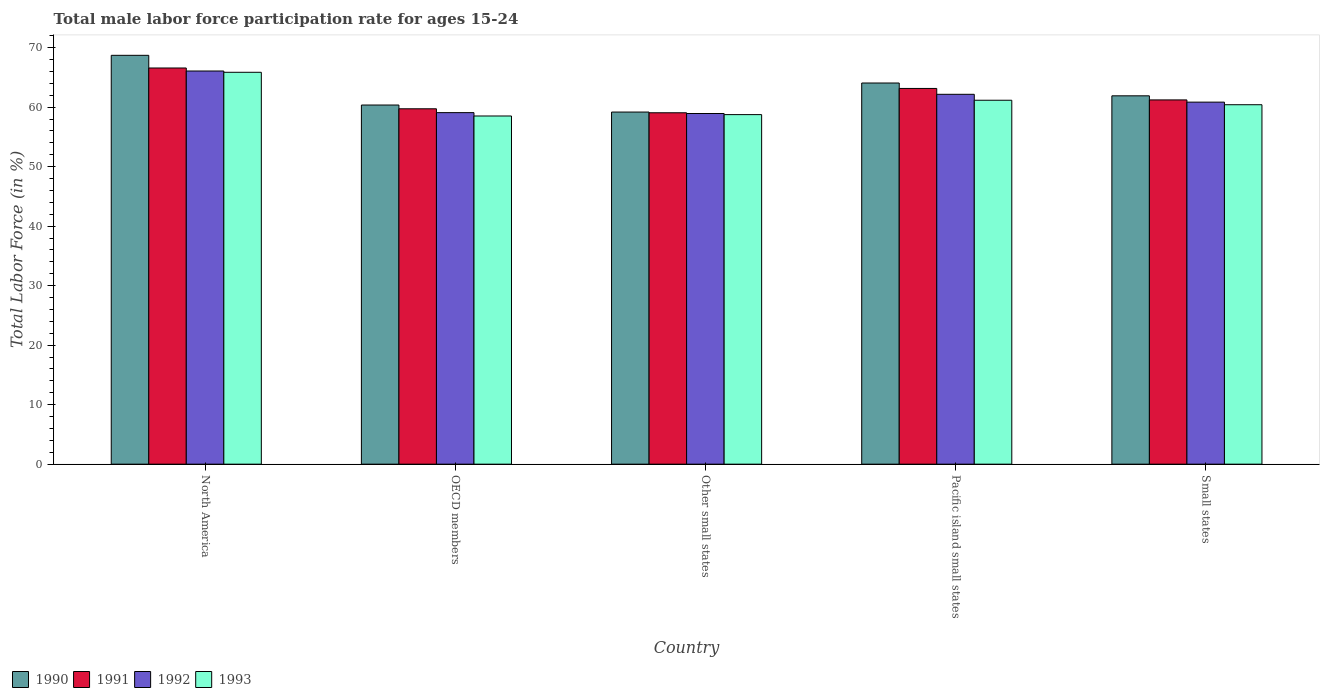Are the number of bars per tick equal to the number of legend labels?
Your answer should be very brief. Yes. Are the number of bars on each tick of the X-axis equal?
Give a very brief answer. Yes. How many bars are there on the 1st tick from the right?
Provide a succinct answer. 4. What is the label of the 3rd group of bars from the left?
Your answer should be compact. Other small states. In how many cases, is the number of bars for a given country not equal to the number of legend labels?
Ensure brevity in your answer.  0. What is the male labor force participation rate in 1990 in North America?
Keep it short and to the point. 68.71. Across all countries, what is the maximum male labor force participation rate in 1990?
Your answer should be very brief. 68.71. Across all countries, what is the minimum male labor force participation rate in 1993?
Your response must be concise. 58.51. In which country was the male labor force participation rate in 1991 maximum?
Your response must be concise. North America. In which country was the male labor force participation rate in 1992 minimum?
Offer a terse response. Other small states. What is the total male labor force participation rate in 1991 in the graph?
Your answer should be very brief. 309.72. What is the difference between the male labor force participation rate in 1992 in OECD members and that in Other small states?
Provide a short and direct response. 0.14. What is the difference between the male labor force participation rate in 1990 in Other small states and the male labor force participation rate in 1992 in North America?
Provide a succinct answer. -6.9. What is the average male labor force participation rate in 1991 per country?
Make the answer very short. 61.94. What is the difference between the male labor force participation rate of/in 1990 and male labor force participation rate of/in 1993 in Other small states?
Make the answer very short. 0.43. In how many countries, is the male labor force participation rate in 1993 greater than 18 %?
Your answer should be compact. 5. What is the ratio of the male labor force participation rate in 1993 in North America to that in Pacific island small states?
Your response must be concise. 1.08. Is the male labor force participation rate in 1993 in OECD members less than that in Pacific island small states?
Provide a short and direct response. Yes. What is the difference between the highest and the second highest male labor force participation rate in 1990?
Offer a terse response. -4.65. What is the difference between the highest and the lowest male labor force participation rate in 1990?
Ensure brevity in your answer.  9.54. In how many countries, is the male labor force participation rate in 1990 greater than the average male labor force participation rate in 1990 taken over all countries?
Give a very brief answer. 2. Is the sum of the male labor force participation rate in 1993 in North America and Other small states greater than the maximum male labor force participation rate in 1992 across all countries?
Your response must be concise. Yes. What does the 3rd bar from the left in North America represents?
Your answer should be compact. 1992. Is it the case that in every country, the sum of the male labor force participation rate in 1993 and male labor force participation rate in 1991 is greater than the male labor force participation rate in 1992?
Offer a terse response. Yes. How many bars are there?
Keep it short and to the point. 20. How many countries are there in the graph?
Provide a succinct answer. 5. What is the difference between two consecutive major ticks on the Y-axis?
Keep it short and to the point. 10. Are the values on the major ticks of Y-axis written in scientific E-notation?
Offer a terse response. No. Does the graph contain any zero values?
Provide a short and direct response. No. Does the graph contain grids?
Offer a very short reply. No. Where does the legend appear in the graph?
Ensure brevity in your answer.  Bottom left. How are the legend labels stacked?
Your answer should be very brief. Horizontal. What is the title of the graph?
Your response must be concise. Total male labor force participation rate for ages 15-24. What is the Total Labor Force (in %) of 1990 in North America?
Offer a terse response. 68.71. What is the Total Labor Force (in %) in 1991 in North America?
Give a very brief answer. 66.58. What is the Total Labor Force (in %) in 1992 in North America?
Offer a very short reply. 66.08. What is the Total Labor Force (in %) of 1993 in North America?
Ensure brevity in your answer.  65.86. What is the Total Labor Force (in %) of 1990 in OECD members?
Your answer should be very brief. 60.36. What is the Total Labor Force (in %) of 1991 in OECD members?
Your answer should be compact. 59.73. What is the Total Labor Force (in %) in 1992 in OECD members?
Make the answer very short. 59.08. What is the Total Labor Force (in %) of 1993 in OECD members?
Make the answer very short. 58.51. What is the Total Labor Force (in %) of 1990 in Other small states?
Offer a very short reply. 59.18. What is the Total Labor Force (in %) in 1991 in Other small states?
Your answer should be very brief. 59.05. What is the Total Labor Force (in %) in 1992 in Other small states?
Your answer should be compact. 58.93. What is the Total Labor Force (in %) in 1993 in Other small states?
Offer a terse response. 58.75. What is the Total Labor Force (in %) in 1990 in Pacific island small states?
Your answer should be very brief. 64.06. What is the Total Labor Force (in %) of 1991 in Pacific island small states?
Provide a short and direct response. 63.15. What is the Total Labor Force (in %) in 1992 in Pacific island small states?
Your answer should be compact. 62.16. What is the Total Labor Force (in %) of 1993 in Pacific island small states?
Offer a terse response. 61.16. What is the Total Labor Force (in %) in 1990 in Small states?
Ensure brevity in your answer.  61.9. What is the Total Labor Force (in %) of 1991 in Small states?
Make the answer very short. 61.22. What is the Total Labor Force (in %) in 1992 in Small states?
Provide a short and direct response. 60.84. What is the Total Labor Force (in %) in 1993 in Small states?
Offer a terse response. 60.41. Across all countries, what is the maximum Total Labor Force (in %) of 1990?
Provide a short and direct response. 68.71. Across all countries, what is the maximum Total Labor Force (in %) in 1991?
Your answer should be very brief. 66.58. Across all countries, what is the maximum Total Labor Force (in %) of 1992?
Provide a succinct answer. 66.08. Across all countries, what is the maximum Total Labor Force (in %) of 1993?
Your answer should be very brief. 65.86. Across all countries, what is the minimum Total Labor Force (in %) of 1990?
Your response must be concise. 59.18. Across all countries, what is the minimum Total Labor Force (in %) in 1991?
Keep it short and to the point. 59.05. Across all countries, what is the minimum Total Labor Force (in %) in 1992?
Offer a very short reply. 58.93. Across all countries, what is the minimum Total Labor Force (in %) of 1993?
Keep it short and to the point. 58.51. What is the total Total Labor Force (in %) in 1990 in the graph?
Provide a succinct answer. 314.21. What is the total Total Labor Force (in %) of 1991 in the graph?
Your answer should be very brief. 309.72. What is the total Total Labor Force (in %) in 1992 in the graph?
Keep it short and to the point. 307.09. What is the total Total Labor Force (in %) in 1993 in the graph?
Provide a short and direct response. 304.69. What is the difference between the Total Labor Force (in %) in 1990 in North America and that in OECD members?
Your answer should be compact. 8.35. What is the difference between the Total Labor Force (in %) in 1991 in North America and that in OECD members?
Your answer should be compact. 6.86. What is the difference between the Total Labor Force (in %) of 1992 in North America and that in OECD members?
Ensure brevity in your answer.  7. What is the difference between the Total Labor Force (in %) of 1993 in North America and that in OECD members?
Provide a succinct answer. 7.34. What is the difference between the Total Labor Force (in %) of 1990 in North America and that in Other small states?
Your response must be concise. 9.54. What is the difference between the Total Labor Force (in %) of 1991 in North America and that in Other small states?
Your answer should be compact. 7.53. What is the difference between the Total Labor Force (in %) of 1992 in North America and that in Other small states?
Give a very brief answer. 7.14. What is the difference between the Total Labor Force (in %) in 1993 in North America and that in Other small states?
Your response must be concise. 7.11. What is the difference between the Total Labor Force (in %) of 1990 in North America and that in Pacific island small states?
Your answer should be compact. 4.65. What is the difference between the Total Labor Force (in %) of 1991 in North America and that in Pacific island small states?
Your answer should be compact. 3.44. What is the difference between the Total Labor Force (in %) of 1992 in North America and that in Pacific island small states?
Ensure brevity in your answer.  3.92. What is the difference between the Total Labor Force (in %) in 1993 in North America and that in Pacific island small states?
Offer a terse response. 4.7. What is the difference between the Total Labor Force (in %) in 1990 in North America and that in Small states?
Give a very brief answer. 6.81. What is the difference between the Total Labor Force (in %) in 1991 in North America and that in Small states?
Make the answer very short. 5.36. What is the difference between the Total Labor Force (in %) of 1992 in North America and that in Small states?
Provide a short and direct response. 5.23. What is the difference between the Total Labor Force (in %) in 1993 in North America and that in Small states?
Offer a very short reply. 5.45. What is the difference between the Total Labor Force (in %) in 1990 in OECD members and that in Other small states?
Ensure brevity in your answer.  1.18. What is the difference between the Total Labor Force (in %) of 1991 in OECD members and that in Other small states?
Offer a very short reply. 0.67. What is the difference between the Total Labor Force (in %) in 1992 in OECD members and that in Other small states?
Your response must be concise. 0.14. What is the difference between the Total Labor Force (in %) of 1993 in OECD members and that in Other small states?
Keep it short and to the point. -0.23. What is the difference between the Total Labor Force (in %) of 1990 in OECD members and that in Pacific island small states?
Offer a very short reply. -3.7. What is the difference between the Total Labor Force (in %) in 1991 in OECD members and that in Pacific island small states?
Your answer should be very brief. -3.42. What is the difference between the Total Labor Force (in %) in 1992 in OECD members and that in Pacific island small states?
Give a very brief answer. -3.08. What is the difference between the Total Labor Force (in %) in 1993 in OECD members and that in Pacific island small states?
Give a very brief answer. -2.65. What is the difference between the Total Labor Force (in %) in 1990 in OECD members and that in Small states?
Offer a terse response. -1.55. What is the difference between the Total Labor Force (in %) in 1991 in OECD members and that in Small states?
Keep it short and to the point. -1.49. What is the difference between the Total Labor Force (in %) in 1992 in OECD members and that in Small states?
Make the answer very short. -1.76. What is the difference between the Total Labor Force (in %) in 1993 in OECD members and that in Small states?
Ensure brevity in your answer.  -1.9. What is the difference between the Total Labor Force (in %) in 1990 in Other small states and that in Pacific island small states?
Offer a very short reply. -4.88. What is the difference between the Total Labor Force (in %) in 1991 in Other small states and that in Pacific island small states?
Provide a short and direct response. -4.09. What is the difference between the Total Labor Force (in %) in 1992 in Other small states and that in Pacific island small states?
Give a very brief answer. -3.23. What is the difference between the Total Labor Force (in %) in 1993 in Other small states and that in Pacific island small states?
Give a very brief answer. -2.42. What is the difference between the Total Labor Force (in %) in 1990 in Other small states and that in Small states?
Keep it short and to the point. -2.73. What is the difference between the Total Labor Force (in %) of 1991 in Other small states and that in Small states?
Keep it short and to the point. -2.16. What is the difference between the Total Labor Force (in %) in 1992 in Other small states and that in Small states?
Your answer should be compact. -1.91. What is the difference between the Total Labor Force (in %) in 1993 in Other small states and that in Small states?
Keep it short and to the point. -1.66. What is the difference between the Total Labor Force (in %) of 1990 in Pacific island small states and that in Small states?
Your answer should be compact. 2.15. What is the difference between the Total Labor Force (in %) of 1991 in Pacific island small states and that in Small states?
Make the answer very short. 1.93. What is the difference between the Total Labor Force (in %) in 1992 in Pacific island small states and that in Small states?
Give a very brief answer. 1.32. What is the difference between the Total Labor Force (in %) of 1993 in Pacific island small states and that in Small states?
Your answer should be compact. 0.75. What is the difference between the Total Labor Force (in %) of 1990 in North America and the Total Labor Force (in %) of 1991 in OECD members?
Provide a succinct answer. 8.99. What is the difference between the Total Labor Force (in %) of 1990 in North America and the Total Labor Force (in %) of 1992 in OECD members?
Provide a succinct answer. 9.63. What is the difference between the Total Labor Force (in %) of 1990 in North America and the Total Labor Force (in %) of 1993 in OECD members?
Provide a succinct answer. 10.2. What is the difference between the Total Labor Force (in %) of 1991 in North America and the Total Labor Force (in %) of 1992 in OECD members?
Give a very brief answer. 7.5. What is the difference between the Total Labor Force (in %) in 1991 in North America and the Total Labor Force (in %) in 1993 in OECD members?
Offer a terse response. 8.07. What is the difference between the Total Labor Force (in %) in 1992 in North America and the Total Labor Force (in %) in 1993 in OECD members?
Give a very brief answer. 7.56. What is the difference between the Total Labor Force (in %) of 1990 in North America and the Total Labor Force (in %) of 1991 in Other small states?
Your response must be concise. 9.66. What is the difference between the Total Labor Force (in %) in 1990 in North America and the Total Labor Force (in %) in 1992 in Other small states?
Keep it short and to the point. 9.78. What is the difference between the Total Labor Force (in %) in 1990 in North America and the Total Labor Force (in %) in 1993 in Other small states?
Make the answer very short. 9.97. What is the difference between the Total Labor Force (in %) of 1991 in North America and the Total Labor Force (in %) of 1992 in Other small states?
Provide a short and direct response. 7.65. What is the difference between the Total Labor Force (in %) of 1991 in North America and the Total Labor Force (in %) of 1993 in Other small states?
Offer a terse response. 7.84. What is the difference between the Total Labor Force (in %) in 1992 in North America and the Total Labor Force (in %) in 1993 in Other small states?
Give a very brief answer. 7.33. What is the difference between the Total Labor Force (in %) of 1990 in North America and the Total Labor Force (in %) of 1991 in Pacific island small states?
Your response must be concise. 5.57. What is the difference between the Total Labor Force (in %) in 1990 in North America and the Total Labor Force (in %) in 1992 in Pacific island small states?
Offer a very short reply. 6.55. What is the difference between the Total Labor Force (in %) of 1990 in North America and the Total Labor Force (in %) of 1993 in Pacific island small states?
Offer a terse response. 7.55. What is the difference between the Total Labor Force (in %) of 1991 in North America and the Total Labor Force (in %) of 1992 in Pacific island small states?
Keep it short and to the point. 4.42. What is the difference between the Total Labor Force (in %) of 1991 in North America and the Total Labor Force (in %) of 1993 in Pacific island small states?
Make the answer very short. 5.42. What is the difference between the Total Labor Force (in %) in 1992 in North America and the Total Labor Force (in %) in 1993 in Pacific island small states?
Offer a very short reply. 4.91. What is the difference between the Total Labor Force (in %) of 1990 in North America and the Total Labor Force (in %) of 1991 in Small states?
Keep it short and to the point. 7.49. What is the difference between the Total Labor Force (in %) in 1990 in North America and the Total Labor Force (in %) in 1992 in Small states?
Your response must be concise. 7.87. What is the difference between the Total Labor Force (in %) in 1990 in North America and the Total Labor Force (in %) in 1993 in Small states?
Offer a very short reply. 8.3. What is the difference between the Total Labor Force (in %) of 1991 in North America and the Total Labor Force (in %) of 1992 in Small states?
Your answer should be very brief. 5.74. What is the difference between the Total Labor Force (in %) of 1991 in North America and the Total Labor Force (in %) of 1993 in Small states?
Ensure brevity in your answer.  6.17. What is the difference between the Total Labor Force (in %) of 1992 in North America and the Total Labor Force (in %) of 1993 in Small states?
Your answer should be very brief. 5.67. What is the difference between the Total Labor Force (in %) of 1990 in OECD members and the Total Labor Force (in %) of 1991 in Other small states?
Provide a succinct answer. 1.3. What is the difference between the Total Labor Force (in %) in 1990 in OECD members and the Total Labor Force (in %) in 1992 in Other small states?
Ensure brevity in your answer.  1.42. What is the difference between the Total Labor Force (in %) in 1990 in OECD members and the Total Labor Force (in %) in 1993 in Other small states?
Provide a short and direct response. 1.61. What is the difference between the Total Labor Force (in %) of 1991 in OECD members and the Total Labor Force (in %) of 1992 in Other small states?
Provide a succinct answer. 0.79. What is the difference between the Total Labor Force (in %) of 1991 in OECD members and the Total Labor Force (in %) of 1993 in Other small states?
Make the answer very short. 0.98. What is the difference between the Total Labor Force (in %) in 1992 in OECD members and the Total Labor Force (in %) in 1993 in Other small states?
Offer a very short reply. 0.33. What is the difference between the Total Labor Force (in %) of 1990 in OECD members and the Total Labor Force (in %) of 1991 in Pacific island small states?
Provide a succinct answer. -2.79. What is the difference between the Total Labor Force (in %) in 1990 in OECD members and the Total Labor Force (in %) in 1992 in Pacific island small states?
Your answer should be compact. -1.8. What is the difference between the Total Labor Force (in %) of 1990 in OECD members and the Total Labor Force (in %) of 1993 in Pacific island small states?
Offer a very short reply. -0.8. What is the difference between the Total Labor Force (in %) of 1991 in OECD members and the Total Labor Force (in %) of 1992 in Pacific island small states?
Your answer should be compact. -2.43. What is the difference between the Total Labor Force (in %) in 1991 in OECD members and the Total Labor Force (in %) in 1993 in Pacific island small states?
Give a very brief answer. -1.44. What is the difference between the Total Labor Force (in %) in 1992 in OECD members and the Total Labor Force (in %) in 1993 in Pacific island small states?
Offer a terse response. -2.08. What is the difference between the Total Labor Force (in %) in 1990 in OECD members and the Total Labor Force (in %) in 1991 in Small states?
Your answer should be very brief. -0.86. What is the difference between the Total Labor Force (in %) in 1990 in OECD members and the Total Labor Force (in %) in 1992 in Small states?
Offer a terse response. -0.48. What is the difference between the Total Labor Force (in %) in 1990 in OECD members and the Total Labor Force (in %) in 1993 in Small states?
Ensure brevity in your answer.  -0.05. What is the difference between the Total Labor Force (in %) in 1991 in OECD members and the Total Labor Force (in %) in 1992 in Small states?
Your answer should be compact. -1.12. What is the difference between the Total Labor Force (in %) in 1991 in OECD members and the Total Labor Force (in %) in 1993 in Small states?
Offer a terse response. -0.68. What is the difference between the Total Labor Force (in %) of 1992 in OECD members and the Total Labor Force (in %) of 1993 in Small states?
Ensure brevity in your answer.  -1.33. What is the difference between the Total Labor Force (in %) of 1990 in Other small states and the Total Labor Force (in %) of 1991 in Pacific island small states?
Give a very brief answer. -3.97. What is the difference between the Total Labor Force (in %) of 1990 in Other small states and the Total Labor Force (in %) of 1992 in Pacific island small states?
Your response must be concise. -2.98. What is the difference between the Total Labor Force (in %) in 1990 in Other small states and the Total Labor Force (in %) in 1993 in Pacific island small states?
Ensure brevity in your answer.  -1.98. What is the difference between the Total Labor Force (in %) in 1991 in Other small states and the Total Labor Force (in %) in 1992 in Pacific island small states?
Make the answer very short. -3.1. What is the difference between the Total Labor Force (in %) in 1991 in Other small states and the Total Labor Force (in %) in 1993 in Pacific island small states?
Offer a very short reply. -2.11. What is the difference between the Total Labor Force (in %) in 1992 in Other small states and the Total Labor Force (in %) in 1993 in Pacific island small states?
Make the answer very short. -2.23. What is the difference between the Total Labor Force (in %) of 1990 in Other small states and the Total Labor Force (in %) of 1991 in Small states?
Your answer should be very brief. -2.04. What is the difference between the Total Labor Force (in %) of 1990 in Other small states and the Total Labor Force (in %) of 1992 in Small states?
Provide a short and direct response. -1.67. What is the difference between the Total Labor Force (in %) of 1990 in Other small states and the Total Labor Force (in %) of 1993 in Small states?
Your answer should be compact. -1.23. What is the difference between the Total Labor Force (in %) of 1991 in Other small states and the Total Labor Force (in %) of 1992 in Small states?
Offer a very short reply. -1.79. What is the difference between the Total Labor Force (in %) of 1991 in Other small states and the Total Labor Force (in %) of 1993 in Small states?
Your response must be concise. -1.35. What is the difference between the Total Labor Force (in %) of 1992 in Other small states and the Total Labor Force (in %) of 1993 in Small states?
Your answer should be very brief. -1.48. What is the difference between the Total Labor Force (in %) of 1990 in Pacific island small states and the Total Labor Force (in %) of 1991 in Small states?
Offer a very short reply. 2.84. What is the difference between the Total Labor Force (in %) in 1990 in Pacific island small states and the Total Labor Force (in %) in 1992 in Small states?
Make the answer very short. 3.22. What is the difference between the Total Labor Force (in %) of 1990 in Pacific island small states and the Total Labor Force (in %) of 1993 in Small states?
Keep it short and to the point. 3.65. What is the difference between the Total Labor Force (in %) in 1991 in Pacific island small states and the Total Labor Force (in %) in 1992 in Small states?
Ensure brevity in your answer.  2.3. What is the difference between the Total Labor Force (in %) in 1991 in Pacific island small states and the Total Labor Force (in %) in 1993 in Small states?
Provide a short and direct response. 2.74. What is the difference between the Total Labor Force (in %) of 1992 in Pacific island small states and the Total Labor Force (in %) of 1993 in Small states?
Your answer should be very brief. 1.75. What is the average Total Labor Force (in %) of 1990 per country?
Your response must be concise. 62.84. What is the average Total Labor Force (in %) in 1991 per country?
Offer a terse response. 61.94. What is the average Total Labor Force (in %) of 1992 per country?
Provide a short and direct response. 61.42. What is the average Total Labor Force (in %) of 1993 per country?
Make the answer very short. 60.94. What is the difference between the Total Labor Force (in %) in 1990 and Total Labor Force (in %) in 1991 in North America?
Offer a very short reply. 2.13. What is the difference between the Total Labor Force (in %) in 1990 and Total Labor Force (in %) in 1992 in North America?
Offer a terse response. 2.64. What is the difference between the Total Labor Force (in %) of 1990 and Total Labor Force (in %) of 1993 in North America?
Offer a terse response. 2.85. What is the difference between the Total Labor Force (in %) in 1991 and Total Labor Force (in %) in 1992 in North America?
Offer a very short reply. 0.51. What is the difference between the Total Labor Force (in %) of 1991 and Total Labor Force (in %) of 1993 in North America?
Provide a short and direct response. 0.72. What is the difference between the Total Labor Force (in %) in 1992 and Total Labor Force (in %) in 1993 in North America?
Your answer should be very brief. 0.22. What is the difference between the Total Labor Force (in %) of 1990 and Total Labor Force (in %) of 1991 in OECD members?
Make the answer very short. 0.63. What is the difference between the Total Labor Force (in %) in 1990 and Total Labor Force (in %) in 1992 in OECD members?
Offer a very short reply. 1.28. What is the difference between the Total Labor Force (in %) in 1990 and Total Labor Force (in %) in 1993 in OECD members?
Keep it short and to the point. 1.84. What is the difference between the Total Labor Force (in %) of 1991 and Total Labor Force (in %) of 1992 in OECD members?
Offer a terse response. 0.65. What is the difference between the Total Labor Force (in %) of 1991 and Total Labor Force (in %) of 1993 in OECD members?
Give a very brief answer. 1.21. What is the difference between the Total Labor Force (in %) in 1992 and Total Labor Force (in %) in 1993 in OECD members?
Offer a terse response. 0.56. What is the difference between the Total Labor Force (in %) in 1990 and Total Labor Force (in %) in 1991 in Other small states?
Give a very brief answer. 0.12. What is the difference between the Total Labor Force (in %) of 1990 and Total Labor Force (in %) of 1992 in Other small states?
Give a very brief answer. 0.24. What is the difference between the Total Labor Force (in %) in 1990 and Total Labor Force (in %) in 1993 in Other small states?
Offer a terse response. 0.43. What is the difference between the Total Labor Force (in %) of 1991 and Total Labor Force (in %) of 1992 in Other small states?
Keep it short and to the point. 0.12. What is the difference between the Total Labor Force (in %) in 1991 and Total Labor Force (in %) in 1993 in Other small states?
Keep it short and to the point. 0.31. What is the difference between the Total Labor Force (in %) in 1992 and Total Labor Force (in %) in 1993 in Other small states?
Offer a terse response. 0.19. What is the difference between the Total Labor Force (in %) in 1990 and Total Labor Force (in %) in 1991 in Pacific island small states?
Give a very brief answer. 0.91. What is the difference between the Total Labor Force (in %) in 1990 and Total Labor Force (in %) in 1992 in Pacific island small states?
Your answer should be very brief. 1.9. What is the difference between the Total Labor Force (in %) in 1990 and Total Labor Force (in %) in 1993 in Pacific island small states?
Offer a very short reply. 2.9. What is the difference between the Total Labor Force (in %) of 1991 and Total Labor Force (in %) of 1992 in Pacific island small states?
Give a very brief answer. 0.99. What is the difference between the Total Labor Force (in %) of 1991 and Total Labor Force (in %) of 1993 in Pacific island small states?
Keep it short and to the point. 1.98. What is the difference between the Total Labor Force (in %) in 1992 and Total Labor Force (in %) in 1993 in Pacific island small states?
Provide a succinct answer. 1. What is the difference between the Total Labor Force (in %) of 1990 and Total Labor Force (in %) of 1991 in Small states?
Your response must be concise. 0.69. What is the difference between the Total Labor Force (in %) in 1990 and Total Labor Force (in %) in 1992 in Small states?
Your answer should be compact. 1.06. What is the difference between the Total Labor Force (in %) of 1990 and Total Labor Force (in %) of 1993 in Small states?
Offer a terse response. 1.5. What is the difference between the Total Labor Force (in %) of 1991 and Total Labor Force (in %) of 1992 in Small states?
Provide a short and direct response. 0.37. What is the difference between the Total Labor Force (in %) of 1991 and Total Labor Force (in %) of 1993 in Small states?
Offer a terse response. 0.81. What is the difference between the Total Labor Force (in %) in 1992 and Total Labor Force (in %) in 1993 in Small states?
Provide a succinct answer. 0.43. What is the ratio of the Total Labor Force (in %) in 1990 in North America to that in OECD members?
Offer a terse response. 1.14. What is the ratio of the Total Labor Force (in %) of 1991 in North America to that in OECD members?
Provide a succinct answer. 1.11. What is the ratio of the Total Labor Force (in %) of 1992 in North America to that in OECD members?
Make the answer very short. 1.12. What is the ratio of the Total Labor Force (in %) in 1993 in North America to that in OECD members?
Keep it short and to the point. 1.13. What is the ratio of the Total Labor Force (in %) in 1990 in North America to that in Other small states?
Make the answer very short. 1.16. What is the ratio of the Total Labor Force (in %) of 1991 in North America to that in Other small states?
Provide a succinct answer. 1.13. What is the ratio of the Total Labor Force (in %) of 1992 in North America to that in Other small states?
Provide a succinct answer. 1.12. What is the ratio of the Total Labor Force (in %) in 1993 in North America to that in Other small states?
Provide a succinct answer. 1.12. What is the ratio of the Total Labor Force (in %) of 1990 in North America to that in Pacific island small states?
Your answer should be very brief. 1.07. What is the ratio of the Total Labor Force (in %) of 1991 in North America to that in Pacific island small states?
Give a very brief answer. 1.05. What is the ratio of the Total Labor Force (in %) of 1992 in North America to that in Pacific island small states?
Ensure brevity in your answer.  1.06. What is the ratio of the Total Labor Force (in %) in 1993 in North America to that in Pacific island small states?
Keep it short and to the point. 1.08. What is the ratio of the Total Labor Force (in %) of 1990 in North America to that in Small states?
Make the answer very short. 1.11. What is the ratio of the Total Labor Force (in %) of 1991 in North America to that in Small states?
Make the answer very short. 1.09. What is the ratio of the Total Labor Force (in %) of 1992 in North America to that in Small states?
Your answer should be very brief. 1.09. What is the ratio of the Total Labor Force (in %) of 1993 in North America to that in Small states?
Make the answer very short. 1.09. What is the ratio of the Total Labor Force (in %) of 1991 in OECD members to that in Other small states?
Provide a succinct answer. 1.01. What is the ratio of the Total Labor Force (in %) in 1990 in OECD members to that in Pacific island small states?
Provide a short and direct response. 0.94. What is the ratio of the Total Labor Force (in %) in 1991 in OECD members to that in Pacific island small states?
Offer a terse response. 0.95. What is the ratio of the Total Labor Force (in %) of 1992 in OECD members to that in Pacific island small states?
Offer a very short reply. 0.95. What is the ratio of the Total Labor Force (in %) in 1993 in OECD members to that in Pacific island small states?
Offer a very short reply. 0.96. What is the ratio of the Total Labor Force (in %) in 1990 in OECD members to that in Small states?
Offer a very short reply. 0.97. What is the ratio of the Total Labor Force (in %) in 1991 in OECD members to that in Small states?
Offer a very short reply. 0.98. What is the ratio of the Total Labor Force (in %) in 1992 in OECD members to that in Small states?
Offer a very short reply. 0.97. What is the ratio of the Total Labor Force (in %) in 1993 in OECD members to that in Small states?
Make the answer very short. 0.97. What is the ratio of the Total Labor Force (in %) of 1990 in Other small states to that in Pacific island small states?
Your response must be concise. 0.92. What is the ratio of the Total Labor Force (in %) of 1991 in Other small states to that in Pacific island small states?
Provide a short and direct response. 0.94. What is the ratio of the Total Labor Force (in %) in 1992 in Other small states to that in Pacific island small states?
Your answer should be very brief. 0.95. What is the ratio of the Total Labor Force (in %) in 1993 in Other small states to that in Pacific island small states?
Your answer should be very brief. 0.96. What is the ratio of the Total Labor Force (in %) in 1990 in Other small states to that in Small states?
Keep it short and to the point. 0.96. What is the ratio of the Total Labor Force (in %) of 1991 in Other small states to that in Small states?
Provide a succinct answer. 0.96. What is the ratio of the Total Labor Force (in %) of 1992 in Other small states to that in Small states?
Keep it short and to the point. 0.97. What is the ratio of the Total Labor Force (in %) of 1993 in Other small states to that in Small states?
Give a very brief answer. 0.97. What is the ratio of the Total Labor Force (in %) of 1990 in Pacific island small states to that in Small states?
Your response must be concise. 1.03. What is the ratio of the Total Labor Force (in %) of 1991 in Pacific island small states to that in Small states?
Offer a terse response. 1.03. What is the ratio of the Total Labor Force (in %) of 1992 in Pacific island small states to that in Small states?
Your answer should be compact. 1.02. What is the ratio of the Total Labor Force (in %) of 1993 in Pacific island small states to that in Small states?
Your response must be concise. 1.01. What is the difference between the highest and the second highest Total Labor Force (in %) in 1990?
Make the answer very short. 4.65. What is the difference between the highest and the second highest Total Labor Force (in %) in 1991?
Provide a succinct answer. 3.44. What is the difference between the highest and the second highest Total Labor Force (in %) in 1992?
Your answer should be compact. 3.92. What is the difference between the highest and the second highest Total Labor Force (in %) of 1993?
Your response must be concise. 4.7. What is the difference between the highest and the lowest Total Labor Force (in %) in 1990?
Ensure brevity in your answer.  9.54. What is the difference between the highest and the lowest Total Labor Force (in %) in 1991?
Provide a succinct answer. 7.53. What is the difference between the highest and the lowest Total Labor Force (in %) of 1992?
Your answer should be very brief. 7.14. What is the difference between the highest and the lowest Total Labor Force (in %) in 1993?
Your response must be concise. 7.34. 